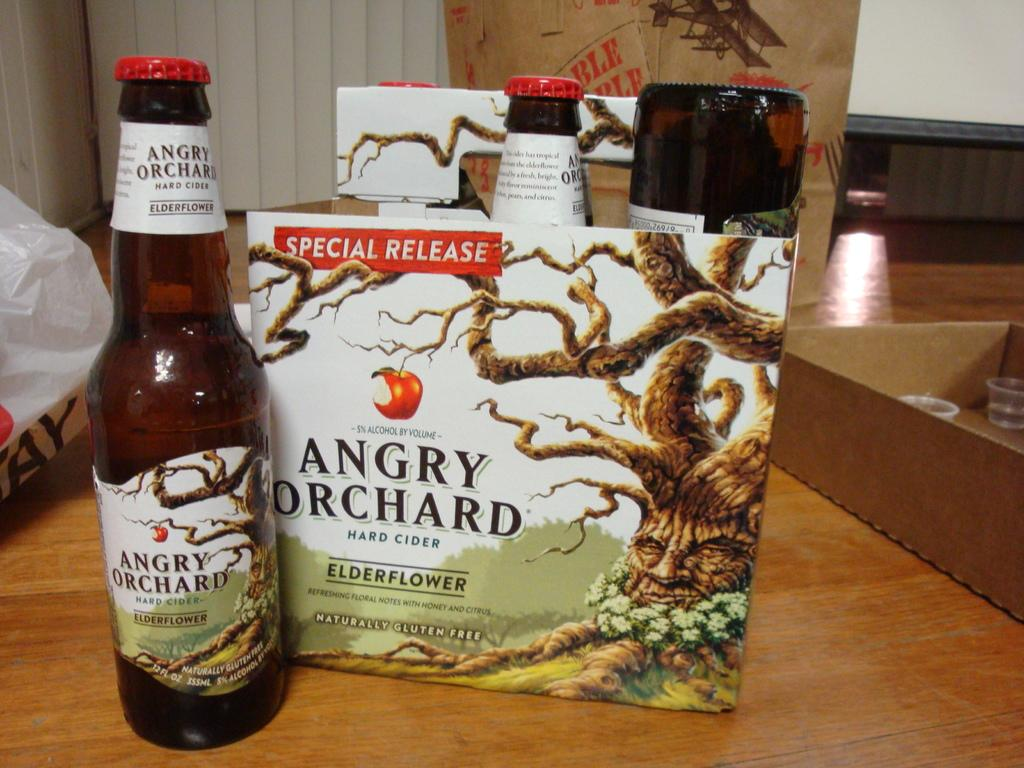<image>
Present a compact description of the photo's key features. A bottle of Angry Orchard hard cider next to the box it came in. 